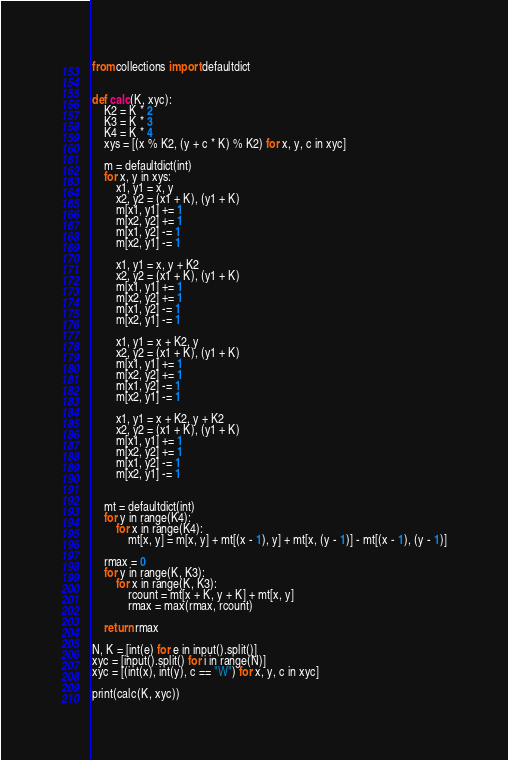Convert code to text. <code><loc_0><loc_0><loc_500><loc_500><_Python_>from collections import defaultdict


def calc(K, xyc):
    K2 = K * 2
    K3 = K * 3
    K4 = K * 4
    xys = [(x % K2, (y + c * K) % K2) for x, y, c in xyc]

    m = defaultdict(int)
    for x, y in xys:
        x1, y1 = x, y
        x2, y2 = (x1 + K), (y1 + K)
        m[x1, y1] += 1
        m[x2, y2] += 1
        m[x1, y2] -= 1
        m[x2, y1] -= 1

        x1, y1 = x, y + K2
        x2, y2 = (x1 + K), (y1 + K)
        m[x1, y1] += 1
        m[x2, y2] += 1
        m[x1, y2] -= 1
        m[x2, y1] -= 1

        x1, y1 = x + K2, y
        x2, y2 = (x1 + K), (y1 + K)
        m[x1, y1] += 1
        m[x2, y2] += 1
        m[x1, y2] -= 1
        m[x2, y1] -= 1

        x1, y1 = x + K2, y + K2
        x2, y2 = (x1 + K), (y1 + K)
        m[x1, y1] += 1
        m[x2, y2] += 1
        m[x1, y2] -= 1
        m[x2, y1] -= 1


    mt = defaultdict(int)
    for y in range(K4):
        for x in range(K4):
            mt[x, y] = m[x, y] + mt[(x - 1), y] + mt[x, (y - 1)] - mt[(x - 1), (y - 1)]

    rmax = 0
    for y in range(K, K3):
        for x in range(K, K3):
            rcount = mt[x + K, y + K] + mt[x, y]
            rmax = max(rmax, rcount)

    return rmax

N, K = [int(e) for e in input().split()]
xyc = [input().split() for i in range(N)]
xyc = [(int(x), int(y), c == "W") for x, y, c in xyc]

print(calc(K, xyc))
</code> 